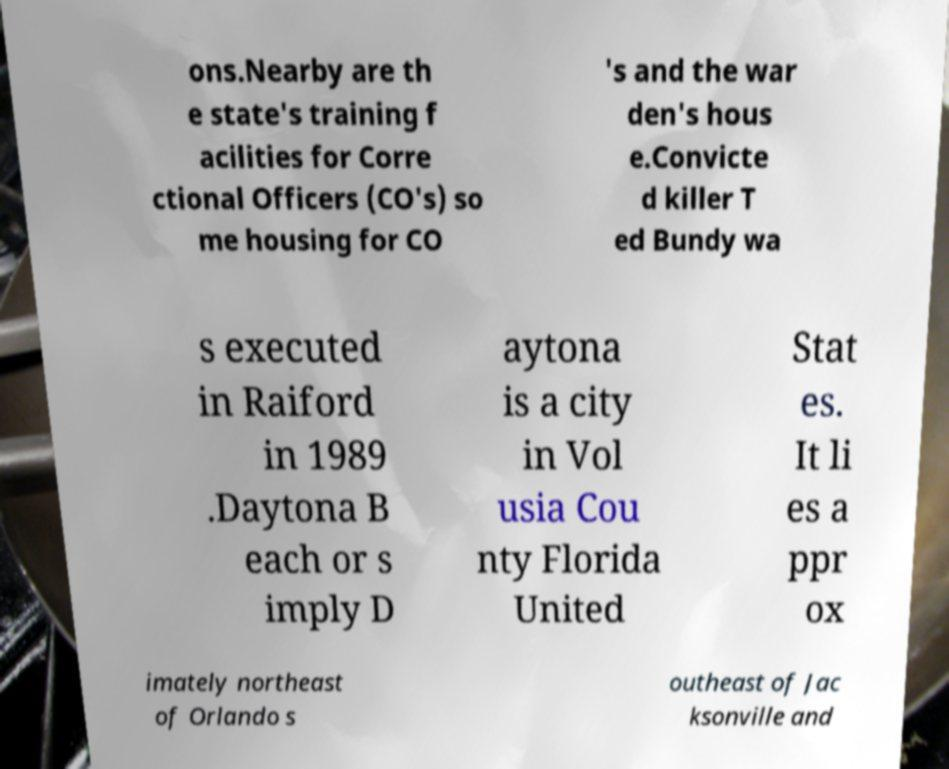There's text embedded in this image that I need extracted. Can you transcribe it verbatim? ons.Nearby are th e state's training f acilities for Corre ctional Officers (CO's) so me housing for CO 's and the war den's hous e.Convicte d killer T ed Bundy wa s executed in Raiford in 1989 .Daytona B each or s imply D aytona is a city in Vol usia Cou nty Florida United Stat es. It li es a ppr ox imately northeast of Orlando s outheast of Jac ksonville and 